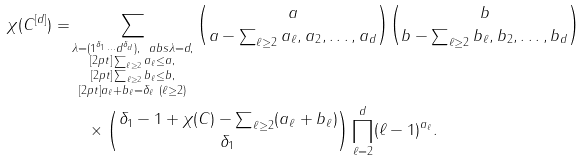<formula> <loc_0><loc_0><loc_500><loc_500>\chi ( C ^ { [ d ] } ) = & \sum _ { \substack { \lambda = ( 1 ^ { \delta _ { 1 } } \cdots d ^ { \delta _ { d } } ) , \, \ a b s { \lambda } = d , \\ [ 2 p t ] \sum _ { \ell \geq 2 } a _ { \ell } \leq a , \\ [ 2 p t ] \sum _ { \ell \geq 2 } b _ { \ell } \leq b , \\ [ 2 p t ] a _ { \ell } + b _ { \ell } = \delta _ { \ell } \ ( \ell \geq 2 ) } } \binom { a } { a - \sum _ { \ell \geq 2 } a _ { \ell } , a _ { 2 } , \dots , a _ { d } } \binom { b } { b - \sum _ { \ell \geq 2 } b _ { \ell } , b _ { 2 } , \dots , b _ { d } } \\ & \quad \times \binom { \delta _ { 1 } - 1 + \chi ( C ) - \sum _ { \ell \geq 2 } ( a _ { \ell } + b _ { \ell } ) } { \delta _ { 1 } } \prod _ { \ell = 2 } ^ { d } ( \ell - 1 ) ^ { a _ { \ell } } .</formula> 